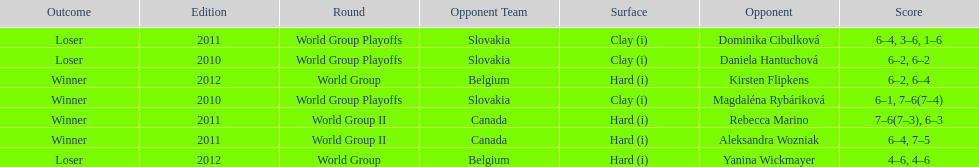Number of games in the match against dominika cibulkova? 3. 